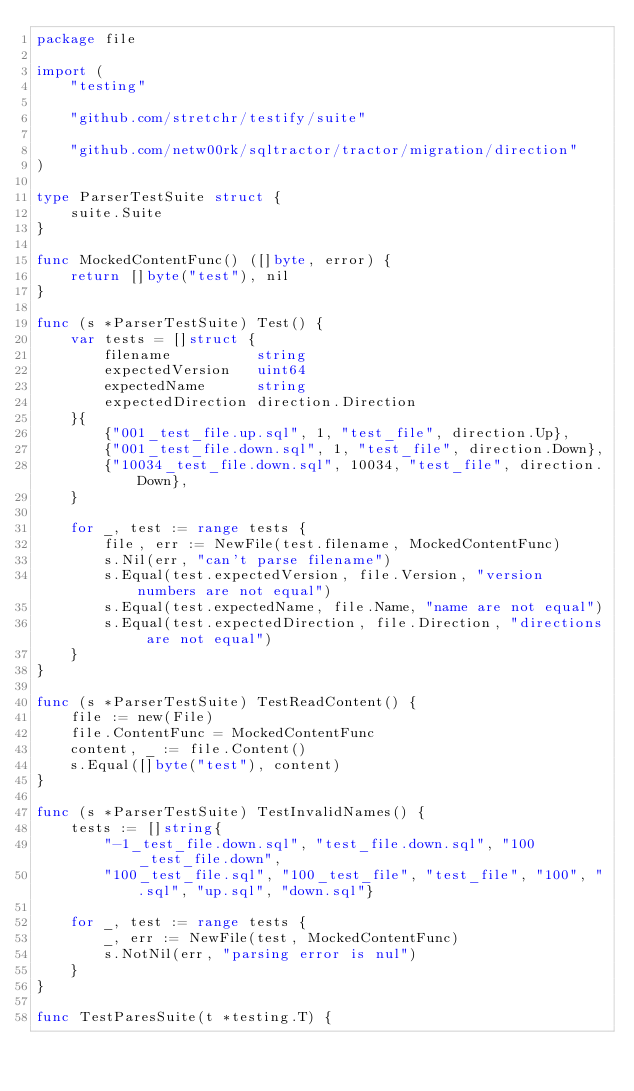Convert code to text. <code><loc_0><loc_0><loc_500><loc_500><_Go_>package file

import (
	"testing"

	"github.com/stretchr/testify/suite"

	"github.com/netw00rk/sqltractor/tractor/migration/direction"
)

type ParserTestSuite struct {
	suite.Suite
}

func MockedContentFunc() ([]byte, error) {
	return []byte("test"), nil
}

func (s *ParserTestSuite) Test() {
	var tests = []struct {
		filename          string
		expectedVersion   uint64
		expectedName      string
		expectedDirection direction.Direction
	}{
		{"001_test_file.up.sql", 1, "test_file", direction.Up},
		{"001_test_file.down.sql", 1, "test_file", direction.Down},
		{"10034_test_file.down.sql", 10034, "test_file", direction.Down},
	}

	for _, test := range tests {
		file, err := NewFile(test.filename, MockedContentFunc)
		s.Nil(err, "can't parse filename")
		s.Equal(test.expectedVersion, file.Version, "version numbers are not equal")
		s.Equal(test.expectedName, file.Name, "name are not equal")
		s.Equal(test.expectedDirection, file.Direction, "directions are not equal")
	}
}

func (s *ParserTestSuite) TestReadContent() {
	file := new(File)
	file.ContentFunc = MockedContentFunc
	content, _ := file.Content()
	s.Equal([]byte("test"), content)
}

func (s *ParserTestSuite) TestInvalidNames() {
	tests := []string{
		"-1_test_file.down.sql", "test_file.down.sql", "100_test_file.down",
		"100_test_file.sql", "100_test_file", "test_file", "100", ".sql", "up.sql", "down.sql"}

	for _, test := range tests {
		_, err := NewFile(test, MockedContentFunc)
		s.NotNil(err, "parsing error is nul")
	}
}

func TestParesSuite(t *testing.T) {</code> 